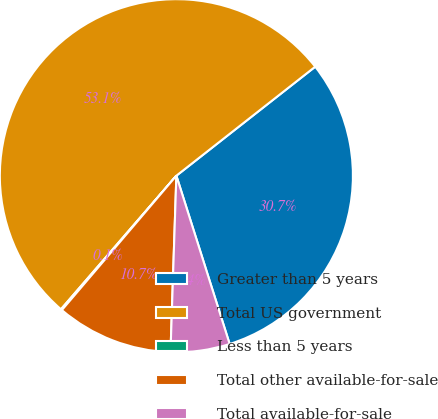<chart> <loc_0><loc_0><loc_500><loc_500><pie_chart><fcel>Greater than 5 years<fcel>Total US government<fcel>Less than 5 years<fcel>Total other available-for-sale<fcel>Total available-for-sale<nl><fcel>30.71%<fcel>53.06%<fcel>0.11%<fcel>10.7%<fcel>5.41%<nl></chart> 